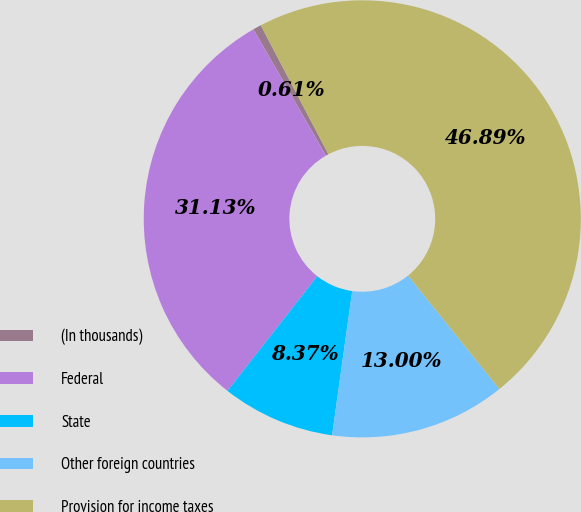Convert chart to OTSL. <chart><loc_0><loc_0><loc_500><loc_500><pie_chart><fcel>(In thousands)<fcel>Federal<fcel>State<fcel>Other foreign countries<fcel>Provision for income taxes<nl><fcel>0.61%<fcel>31.13%<fcel>8.37%<fcel>13.0%<fcel>46.89%<nl></chart> 